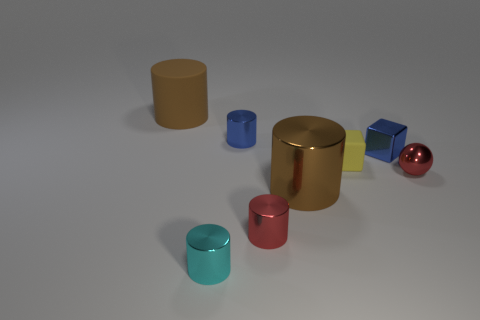Subtract all brown rubber cylinders. How many cylinders are left? 4 Subtract 2 cylinders. How many cylinders are left? 3 Subtract all blue cylinders. How many cylinders are left? 4 Add 1 shiny objects. How many objects exist? 9 Subtract all red cylinders. Subtract all gray blocks. How many cylinders are left? 4 Subtract all spheres. How many objects are left? 7 Add 4 big brown matte cylinders. How many big brown matte cylinders are left? 5 Add 4 gray rubber cylinders. How many gray rubber cylinders exist? 4 Subtract 1 yellow blocks. How many objects are left? 7 Subtract all small brown shiny cylinders. Subtract all yellow blocks. How many objects are left? 7 